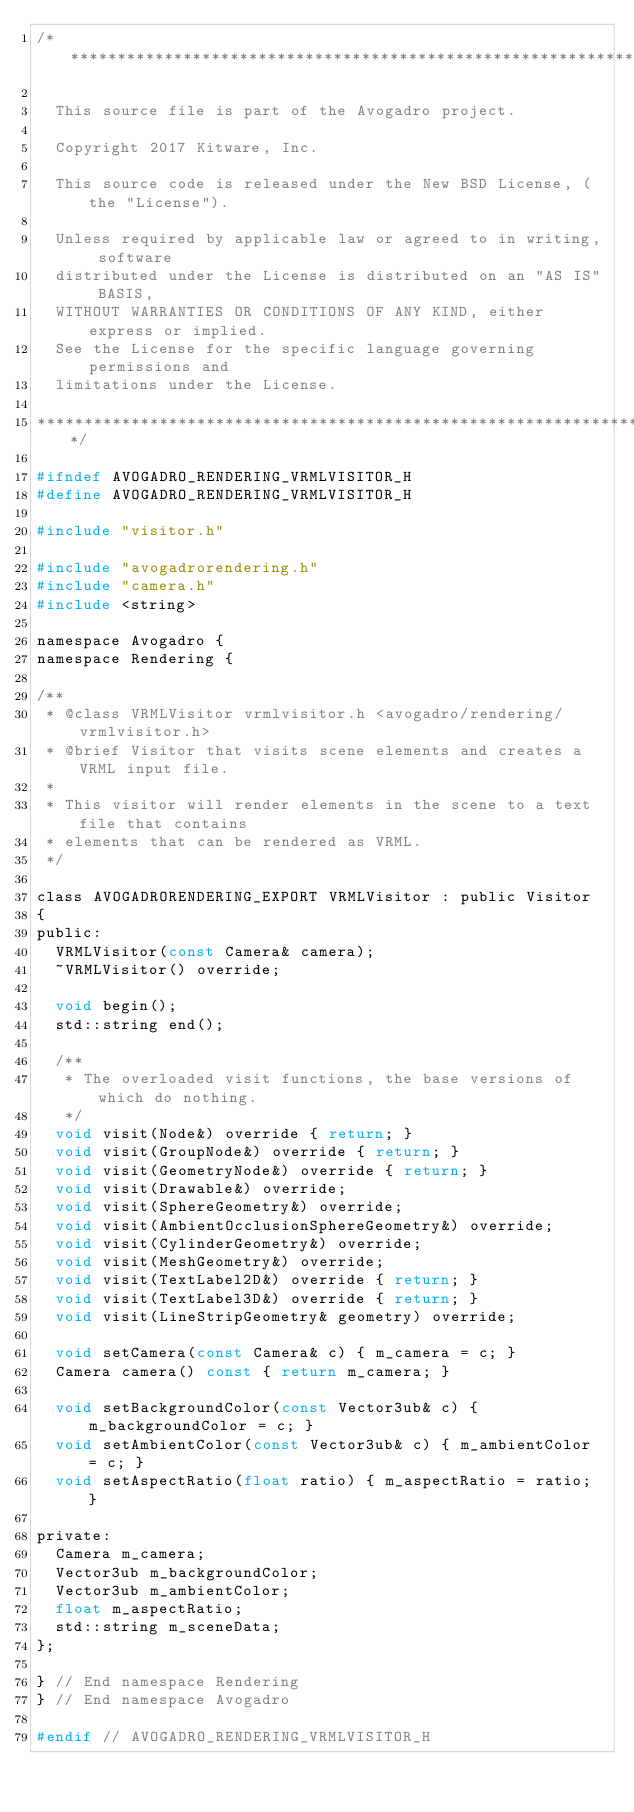<code> <loc_0><loc_0><loc_500><loc_500><_C_>/******************************************************************************

  This source file is part of the Avogadro project.

  Copyright 2017 Kitware, Inc.

  This source code is released under the New BSD License, (the "License").

  Unless required by applicable law or agreed to in writing, software
  distributed under the License is distributed on an "AS IS" BASIS,
  WITHOUT WARRANTIES OR CONDITIONS OF ANY KIND, either express or implied.
  See the License for the specific language governing permissions and
  limitations under the License.

******************************************************************************/

#ifndef AVOGADRO_RENDERING_VRMLVISITOR_H
#define AVOGADRO_RENDERING_VRMLVISITOR_H

#include "visitor.h"

#include "avogadrorendering.h"
#include "camera.h"
#include <string>

namespace Avogadro {
namespace Rendering {

/**
 * @class VRMLVisitor vrmlvisitor.h <avogadro/rendering/vrmlvisitor.h>
 * @brief Visitor that visits scene elements and creates a VRML input file.
 *
 * This visitor will render elements in the scene to a text file that contains
 * elements that can be rendered as VRML.
 */

class AVOGADRORENDERING_EXPORT VRMLVisitor : public Visitor
{
public:
  VRMLVisitor(const Camera& camera);
  ~VRMLVisitor() override;

  void begin();
  std::string end();

  /**
   * The overloaded visit functions, the base versions of which do nothing.
   */
  void visit(Node&) override { return; }
  void visit(GroupNode&) override { return; }
  void visit(GeometryNode&) override { return; }
  void visit(Drawable&) override;
  void visit(SphereGeometry&) override;
  void visit(AmbientOcclusionSphereGeometry&) override;
  void visit(CylinderGeometry&) override;
  void visit(MeshGeometry&) override;
  void visit(TextLabel2D&) override { return; }
  void visit(TextLabel3D&) override { return; }
  void visit(LineStripGeometry& geometry) override;

  void setCamera(const Camera& c) { m_camera = c; }
  Camera camera() const { return m_camera; }

  void setBackgroundColor(const Vector3ub& c) { m_backgroundColor = c; }
  void setAmbientColor(const Vector3ub& c) { m_ambientColor = c; }
  void setAspectRatio(float ratio) { m_aspectRatio = ratio; }

private:
  Camera m_camera;
  Vector3ub m_backgroundColor;
  Vector3ub m_ambientColor;
  float m_aspectRatio;
  std::string m_sceneData;
};

} // End namespace Rendering
} // End namespace Avogadro

#endif // AVOGADRO_RENDERING_VRMLVISITOR_H
</code> 